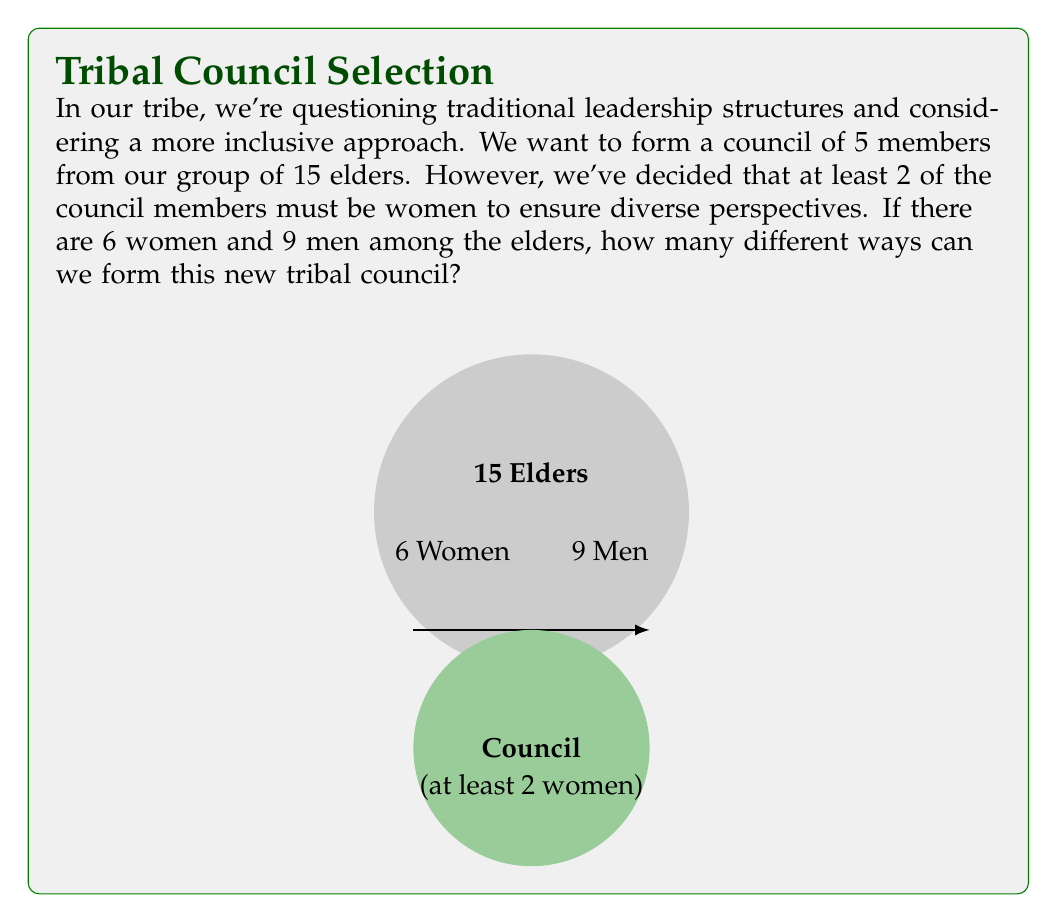Help me with this question. Let's approach this step-by-step:

1) We need to consider three possible scenarios:
   a) 2 women and 3 men
   b) 3 women and 2 men
   c) 4 women and 1 man
   d) 5 women and 0 men (not possible as we only have 6 women)

2) Let's calculate each scenario:

   a) 2 women and 3 men:
      Women: $\binom{6}{2}$ ways to choose 2 from 6
      Men: $\binom{9}{3}$ ways to choose 3 from 9
      Total: $\binom{6}{2} \times \binom{9}{3}$

   b) 3 women and 2 men:
      Women: $\binom{6}{3}$ ways to choose 3 from 6
      Men: $\binom{9}{2}$ ways to choose 2 from 9
      Total: $\binom{6}{3} \times \binom{9}{2}$

   c) 4 women and 1 man:
      Women: $\binom{6}{4}$ ways to choose 4 from 6
      Men: $\binom{9}{1}$ ways to choose 1 from 9
      Total: $\binom{6}{4} \times \binom{9}{1}$

3) Now, let's calculate each combination:

   a) $\binom{6}{2} \times \binom{9}{3} = 15 \times 84 = 1260$
   b) $\binom{6}{3} \times \binom{9}{2} = 20 \times 36 = 720$
   c) $\binom{6}{4} \times \binom{9}{1} = 15 \times 9 = 135$

4) The total number of possible combinations is the sum of all these scenarios:

   Total = 1260 + 720 + 135 = 2115

Therefore, there are 2115 different ways to form the new tribal council.
Answer: 2115 